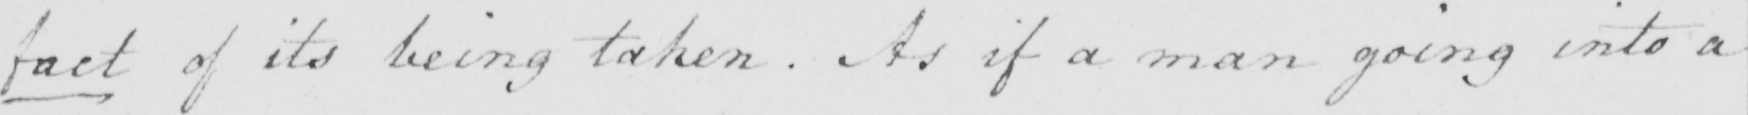What text is written in this handwritten line? fact of its being taken . As if a man going in to a 